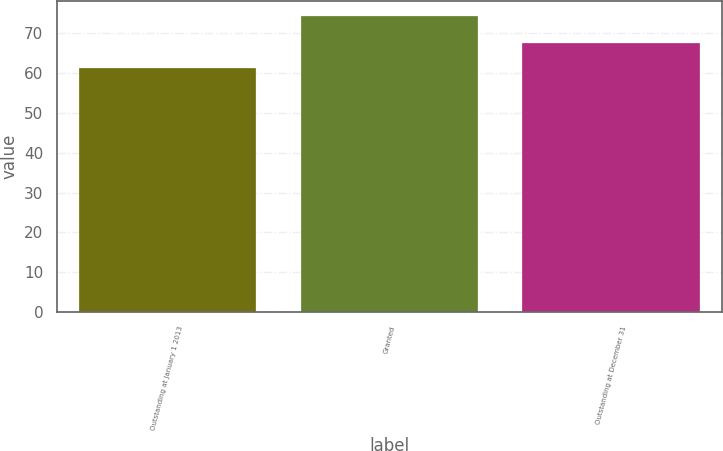Convert chart to OTSL. <chart><loc_0><loc_0><loc_500><loc_500><bar_chart><fcel>Outstanding at January 1 2013<fcel>Granted<fcel>Outstanding at December 31<nl><fcel>61.11<fcel>74.22<fcel>67.42<nl></chart> 